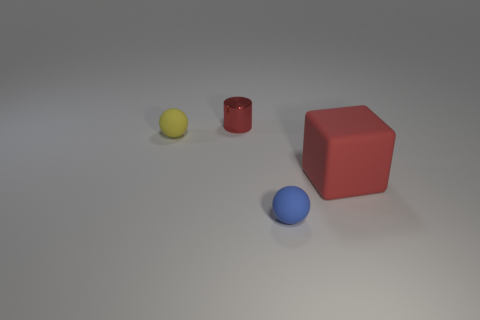There is a tiny sphere in front of the ball that is on the left side of the small blue ball; what number of tiny red things are to the right of it?
Offer a very short reply. 0. The large block is what color?
Your answer should be compact. Red. How many other things are the same size as the red cylinder?
Ensure brevity in your answer.  2. What is the material of the other small thing that is the same shape as the blue matte object?
Your response must be concise. Rubber. What is the material of the red object that is left of the ball in front of the small rubber object behind the red rubber block?
Provide a short and direct response. Metal. What size is the red cube that is made of the same material as the yellow sphere?
Provide a short and direct response. Large. There is a large matte cube that is to the right of the small metallic object; does it have the same color as the small object behind the yellow matte ball?
Your answer should be very brief. Yes. The rubber thing that is behind the large red rubber object is what color?
Provide a short and direct response. Yellow. Is the size of the red thing to the left of the rubber block the same as the big cube?
Provide a succinct answer. No. Are there fewer small yellow matte things than tiny gray metallic spheres?
Your answer should be compact. No. 